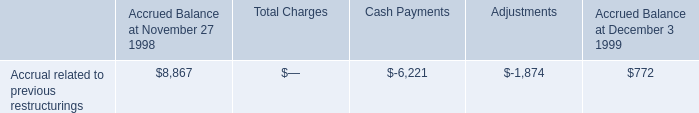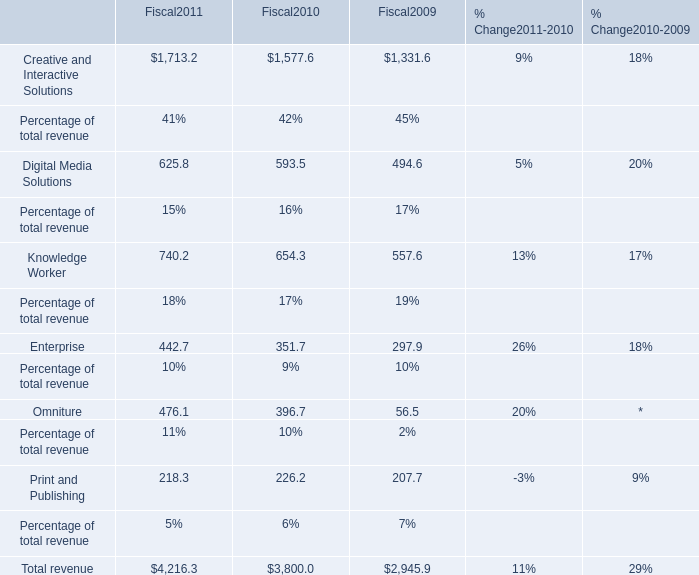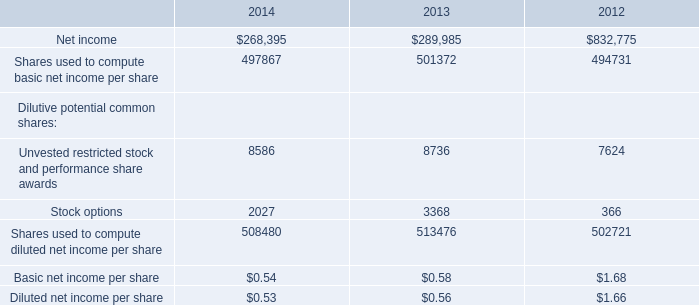What is the average amount of Creative and Interactive Solutions of Fiscal2010, and Net income of 2013 ? 
Computations: ((1577.6 + 289985.0) / 2)
Answer: 145781.3. What is the sum of Creative and Interactive Solutions of Fiscal2009, Net income of 2013, and Shares used to compute basic net income per share of 2012 ? 
Computations: ((1331.6 + 289985.0) + 494731.0)
Answer: 786047.6. 